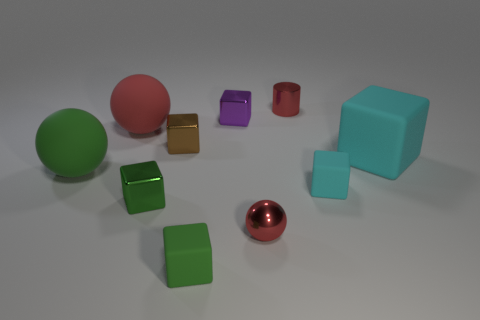Subtract all big cyan rubber cubes. How many cubes are left? 5 Subtract all purple blocks. How many blocks are left? 5 Subtract all green blocks. Subtract all red balls. How many blocks are left? 4 Subtract all blocks. How many objects are left? 4 Add 5 purple matte things. How many purple matte things exist? 5 Subtract 2 green cubes. How many objects are left? 8 Subtract all small cyan cubes. Subtract all small purple metallic things. How many objects are left? 8 Add 5 shiny balls. How many shiny balls are left? 6 